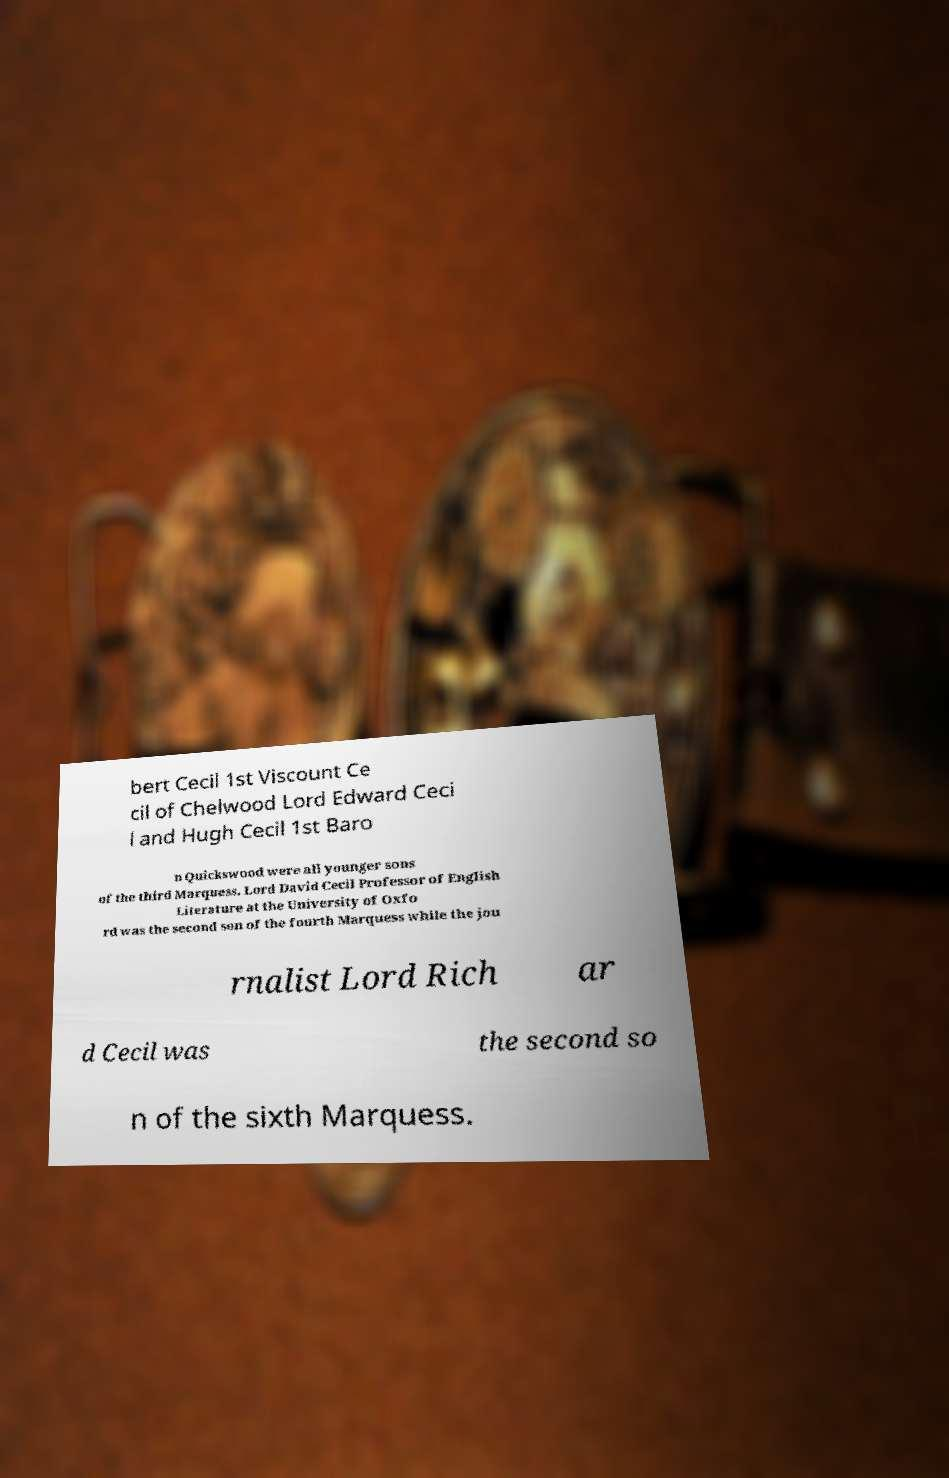Could you extract and type out the text from this image? bert Cecil 1st Viscount Ce cil of Chelwood Lord Edward Ceci l and Hugh Cecil 1st Baro n Quickswood were all younger sons of the third Marquess. Lord David Cecil Professor of English Literature at the University of Oxfo rd was the second son of the fourth Marquess while the jou rnalist Lord Rich ar d Cecil was the second so n of the sixth Marquess. 